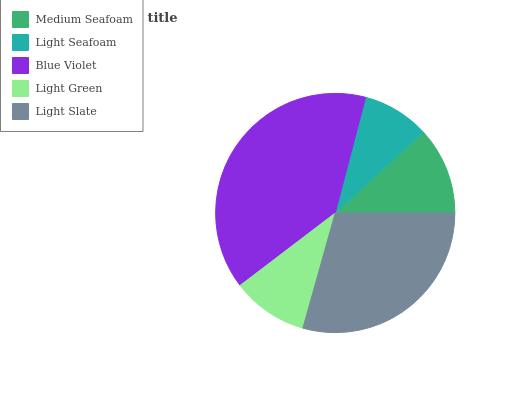Is Light Seafoam the minimum?
Answer yes or no. Yes. Is Blue Violet the maximum?
Answer yes or no. Yes. Is Blue Violet the minimum?
Answer yes or no. No. Is Light Seafoam the maximum?
Answer yes or no. No. Is Blue Violet greater than Light Seafoam?
Answer yes or no. Yes. Is Light Seafoam less than Blue Violet?
Answer yes or no. Yes. Is Light Seafoam greater than Blue Violet?
Answer yes or no. No. Is Blue Violet less than Light Seafoam?
Answer yes or no. No. Is Medium Seafoam the high median?
Answer yes or no. Yes. Is Medium Seafoam the low median?
Answer yes or no. Yes. Is Light Seafoam the high median?
Answer yes or no. No. Is Blue Violet the low median?
Answer yes or no. No. 